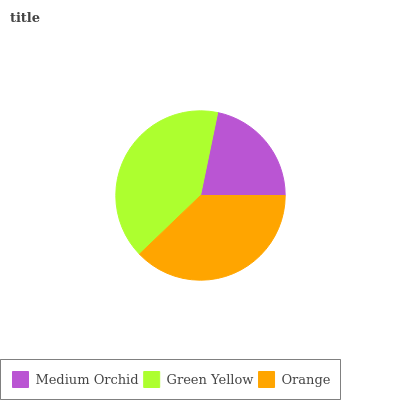Is Medium Orchid the minimum?
Answer yes or no. Yes. Is Green Yellow the maximum?
Answer yes or no. Yes. Is Orange the minimum?
Answer yes or no. No. Is Orange the maximum?
Answer yes or no. No. Is Green Yellow greater than Orange?
Answer yes or no. Yes. Is Orange less than Green Yellow?
Answer yes or no. Yes. Is Orange greater than Green Yellow?
Answer yes or no. No. Is Green Yellow less than Orange?
Answer yes or no. No. Is Orange the high median?
Answer yes or no. Yes. Is Orange the low median?
Answer yes or no. Yes. Is Green Yellow the high median?
Answer yes or no. No. Is Green Yellow the low median?
Answer yes or no. No. 